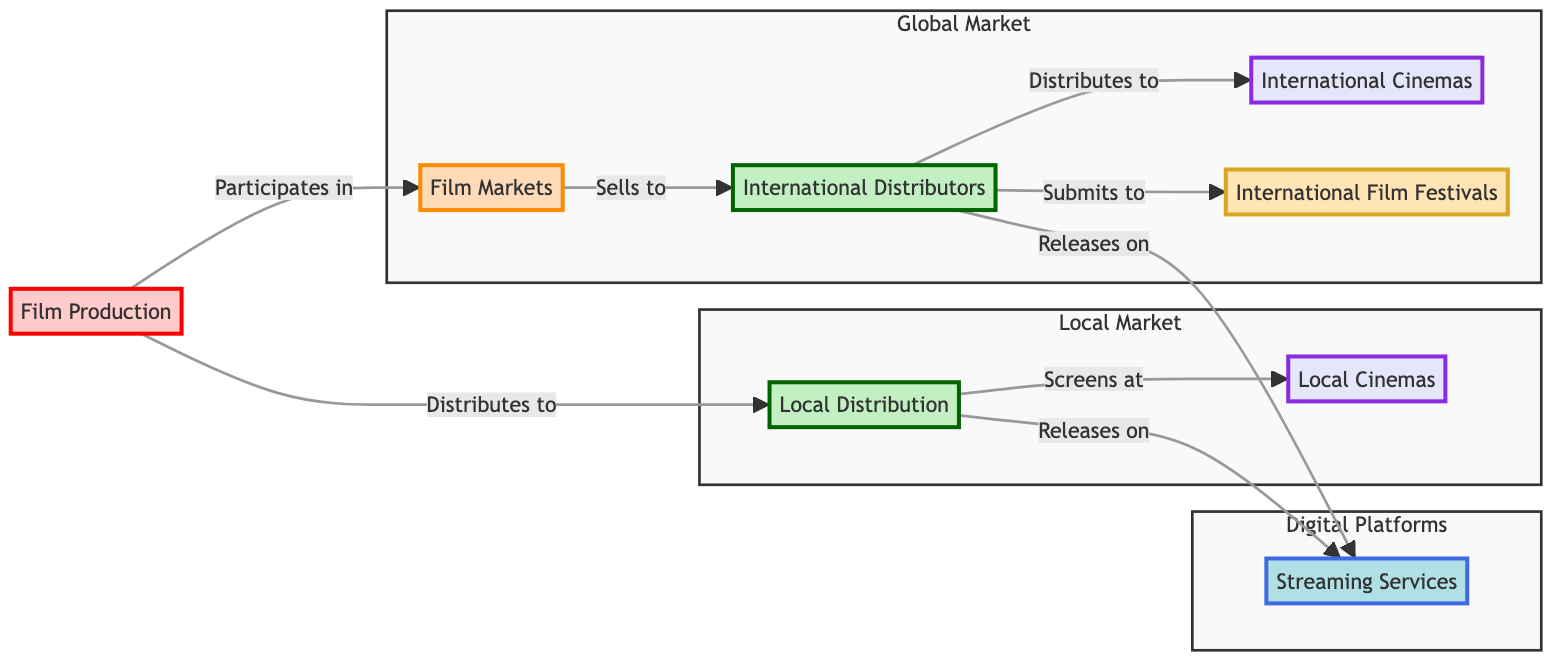What are the examples of local distribution companies? The node labeled "Local Distribution" lists "Eveready Pictures" and "HKC Entertainment" as examples. This information is directly found within the node itself.
Answer: Eveready Pictures, HKC Entertainment How many nodes are in this diagram? By counting all the labeled nodes in the diagram, including Film Production, Local Distribution, Film Markets, Local Cinemas, Streaming Services, International Distributors, and International Film Festivals, we find a total of 7 nodes.
Answer: 7 Which node connects both local cinemas and streaming services? The "Local Distribution" node connects to both "Local Cinemas" and "Streaming Services" through direct edges. The diagram visually indicates these relationships clearly.
Answer: Local Distribution What is the relationship between film markets and international distributors? Film markets "sells to" international distributors, as represented by the edge directed from "Film Markets" to "International Distributors." The wording on the arrow indicates this relationship.
Answer: Sells to Which category includes the node "Toronto International Film Festival"? The node "Toronto International Film Festival" is categorized under "International Film Festivals." This is indicated by the label and the organizational structure of the diagram, where it is associated with film festivals distinctly.
Answer: International Film Festivals How do international distributors release Pakistani films to audiences? International distributors release films through "International Cinemas" and "Streaming Services," as indicated by the arrows pointing towards these two nodes. They handle the distribution both physically and digitally.
Answer: International Cinemas, Streaming Services What comes after local distribution in terms of film circulation? The flow after "Local Distribution" goes to both "Local Cinemas" and "Streaming Services," as shown by the directed edges. This indicates two paths that films follow after local distribution.
Answer: Local Cinemas, Streaming Services How many types of distribution channels are present in this diagram? The diagram shows two types of distribution channels: local and international. Local channels include local distribution and local cinemas, while international channels include international distributors, international cinemas, and film festivals. Combining these, we find a total of two types.
Answer: 2 